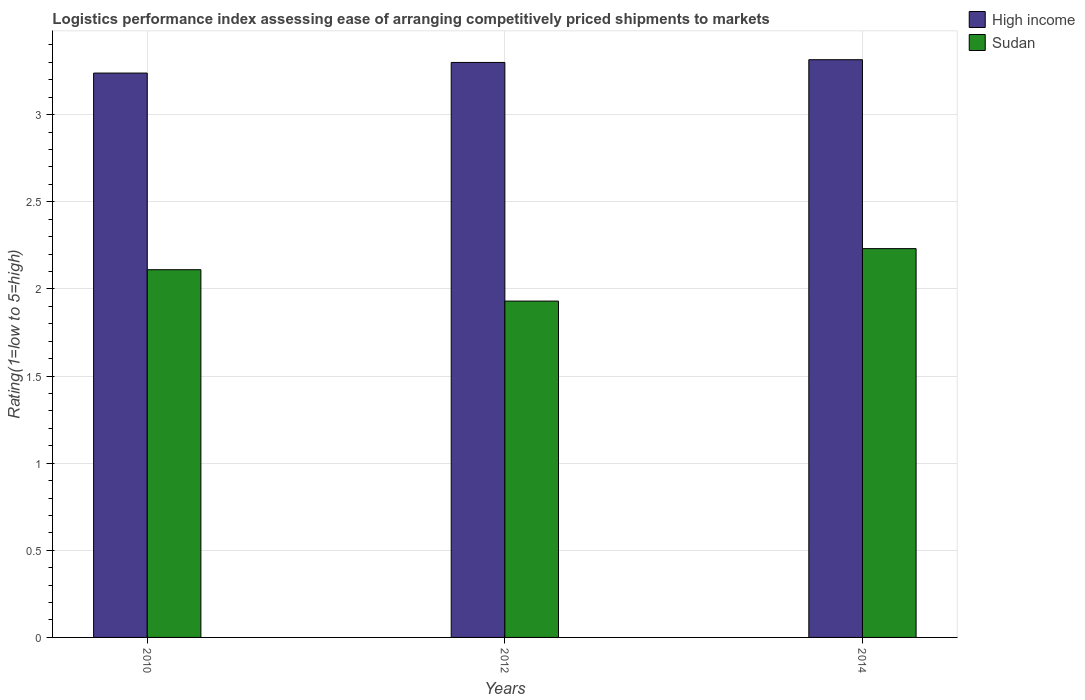Are the number of bars per tick equal to the number of legend labels?
Make the answer very short. Yes. Are the number of bars on each tick of the X-axis equal?
Offer a very short reply. Yes. How many bars are there on the 3rd tick from the right?
Provide a succinct answer. 2. What is the Logistic performance index in Sudan in 2014?
Provide a short and direct response. 2.23. Across all years, what is the maximum Logistic performance index in Sudan?
Your response must be concise. 2.23. Across all years, what is the minimum Logistic performance index in Sudan?
Make the answer very short. 1.93. In which year was the Logistic performance index in High income maximum?
Make the answer very short. 2014. What is the total Logistic performance index in Sudan in the graph?
Ensure brevity in your answer.  6.27. What is the difference between the Logistic performance index in Sudan in 2010 and that in 2012?
Your answer should be very brief. 0.18. What is the difference between the Logistic performance index in Sudan in 2014 and the Logistic performance index in High income in 2012?
Ensure brevity in your answer.  -1.07. What is the average Logistic performance index in High income per year?
Offer a terse response. 3.28. In the year 2010, what is the difference between the Logistic performance index in Sudan and Logistic performance index in High income?
Your answer should be compact. -1.13. In how many years, is the Logistic performance index in High income greater than 1.4?
Provide a short and direct response. 3. What is the ratio of the Logistic performance index in Sudan in 2010 to that in 2014?
Offer a terse response. 0.95. Is the Logistic performance index in High income in 2010 less than that in 2014?
Your answer should be compact. Yes. What is the difference between the highest and the second highest Logistic performance index in Sudan?
Provide a short and direct response. 0.12. What is the difference between the highest and the lowest Logistic performance index in High income?
Offer a terse response. 0.08. Is the sum of the Logistic performance index in Sudan in 2010 and 2014 greater than the maximum Logistic performance index in High income across all years?
Offer a terse response. Yes. What does the 2nd bar from the right in 2012 represents?
Your answer should be compact. High income. How many bars are there?
Give a very brief answer. 6. Are all the bars in the graph horizontal?
Give a very brief answer. No. How many years are there in the graph?
Your response must be concise. 3. What is the difference between two consecutive major ticks on the Y-axis?
Your answer should be compact. 0.5. Does the graph contain any zero values?
Your response must be concise. No. Does the graph contain grids?
Provide a short and direct response. Yes. Where does the legend appear in the graph?
Your answer should be compact. Top right. How many legend labels are there?
Give a very brief answer. 2. What is the title of the graph?
Provide a succinct answer. Logistics performance index assessing ease of arranging competitively priced shipments to markets. Does "Luxembourg" appear as one of the legend labels in the graph?
Offer a terse response. No. What is the label or title of the X-axis?
Your response must be concise. Years. What is the label or title of the Y-axis?
Ensure brevity in your answer.  Rating(1=low to 5=high). What is the Rating(1=low to 5=high) of High income in 2010?
Give a very brief answer. 3.24. What is the Rating(1=low to 5=high) in Sudan in 2010?
Offer a terse response. 2.11. What is the Rating(1=low to 5=high) in High income in 2012?
Provide a succinct answer. 3.3. What is the Rating(1=low to 5=high) of Sudan in 2012?
Provide a succinct answer. 1.93. What is the Rating(1=low to 5=high) of High income in 2014?
Give a very brief answer. 3.32. What is the Rating(1=low to 5=high) in Sudan in 2014?
Your response must be concise. 2.23. Across all years, what is the maximum Rating(1=low to 5=high) of High income?
Keep it short and to the point. 3.32. Across all years, what is the maximum Rating(1=low to 5=high) in Sudan?
Offer a very short reply. 2.23. Across all years, what is the minimum Rating(1=low to 5=high) in High income?
Your response must be concise. 3.24. Across all years, what is the minimum Rating(1=low to 5=high) of Sudan?
Offer a terse response. 1.93. What is the total Rating(1=low to 5=high) of High income in the graph?
Give a very brief answer. 9.85. What is the total Rating(1=low to 5=high) of Sudan in the graph?
Provide a succinct answer. 6.27. What is the difference between the Rating(1=low to 5=high) in High income in 2010 and that in 2012?
Offer a very short reply. -0.06. What is the difference between the Rating(1=low to 5=high) in Sudan in 2010 and that in 2012?
Your answer should be very brief. 0.18. What is the difference between the Rating(1=low to 5=high) of High income in 2010 and that in 2014?
Make the answer very short. -0.08. What is the difference between the Rating(1=low to 5=high) in Sudan in 2010 and that in 2014?
Your response must be concise. -0.12. What is the difference between the Rating(1=low to 5=high) in High income in 2012 and that in 2014?
Your answer should be very brief. -0.02. What is the difference between the Rating(1=low to 5=high) of Sudan in 2012 and that in 2014?
Your response must be concise. -0.3. What is the difference between the Rating(1=low to 5=high) in High income in 2010 and the Rating(1=low to 5=high) in Sudan in 2012?
Make the answer very short. 1.31. What is the difference between the Rating(1=low to 5=high) of High income in 2010 and the Rating(1=low to 5=high) of Sudan in 2014?
Offer a terse response. 1.01. What is the difference between the Rating(1=low to 5=high) of High income in 2012 and the Rating(1=low to 5=high) of Sudan in 2014?
Keep it short and to the point. 1.07. What is the average Rating(1=low to 5=high) of High income per year?
Provide a short and direct response. 3.28. What is the average Rating(1=low to 5=high) of Sudan per year?
Your answer should be compact. 2.09. In the year 2010, what is the difference between the Rating(1=low to 5=high) in High income and Rating(1=low to 5=high) in Sudan?
Ensure brevity in your answer.  1.13. In the year 2012, what is the difference between the Rating(1=low to 5=high) of High income and Rating(1=low to 5=high) of Sudan?
Ensure brevity in your answer.  1.37. In the year 2014, what is the difference between the Rating(1=low to 5=high) of High income and Rating(1=low to 5=high) of Sudan?
Offer a very short reply. 1.08. What is the ratio of the Rating(1=low to 5=high) in High income in 2010 to that in 2012?
Your response must be concise. 0.98. What is the ratio of the Rating(1=low to 5=high) of Sudan in 2010 to that in 2012?
Offer a terse response. 1.09. What is the ratio of the Rating(1=low to 5=high) of High income in 2010 to that in 2014?
Make the answer very short. 0.98. What is the ratio of the Rating(1=low to 5=high) of Sudan in 2010 to that in 2014?
Offer a very short reply. 0.95. What is the ratio of the Rating(1=low to 5=high) of High income in 2012 to that in 2014?
Your answer should be very brief. 1. What is the ratio of the Rating(1=low to 5=high) in Sudan in 2012 to that in 2014?
Keep it short and to the point. 0.87. What is the difference between the highest and the second highest Rating(1=low to 5=high) of High income?
Offer a terse response. 0.02. What is the difference between the highest and the second highest Rating(1=low to 5=high) of Sudan?
Offer a terse response. 0.12. What is the difference between the highest and the lowest Rating(1=low to 5=high) of High income?
Your response must be concise. 0.08. What is the difference between the highest and the lowest Rating(1=low to 5=high) in Sudan?
Your response must be concise. 0.3. 